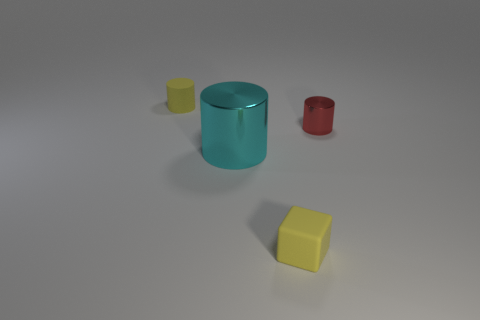Is there any other thing that has the same size as the cyan metallic cylinder?
Your answer should be compact. No. Are there any blue cylinders that have the same material as the tiny block?
Your answer should be compact. No. What material is the yellow thing that is to the right of the tiny yellow rubber thing that is behind the cyan thing made of?
Offer a very short reply. Rubber. Are there an equal number of red shiny cylinders that are behind the small metallic thing and objects that are right of the yellow rubber cube?
Provide a short and direct response. No. Does the large cyan thing have the same shape as the tiny red object?
Ensure brevity in your answer.  Yes. There is a thing that is both in front of the small red metal thing and to the right of the cyan shiny cylinder; what is it made of?
Ensure brevity in your answer.  Rubber. What number of yellow things have the same shape as the red thing?
Provide a succinct answer. 1. There is a thing to the right of the yellow matte object that is to the right of the cylinder that is left of the large thing; what is its size?
Give a very brief answer. Small. Is the number of tiny objects in front of the small metallic cylinder greater than the number of big purple balls?
Your answer should be compact. Yes. Are there any tiny rubber things?
Make the answer very short. Yes. 